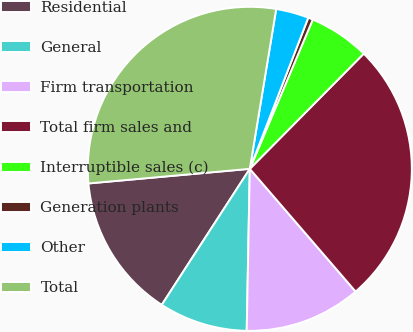Convert chart. <chart><loc_0><loc_0><loc_500><loc_500><pie_chart><fcel>Residential<fcel>General<fcel>Firm transportation<fcel>Total firm sales and<fcel>Interruptible sales (c)<fcel>Generation plants<fcel>Other<fcel>Total<nl><fcel>14.42%<fcel>8.84%<fcel>11.63%<fcel>26.26%<fcel>6.06%<fcel>0.48%<fcel>3.27%<fcel>29.04%<nl></chart> 